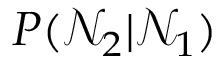Convert formula to latex. <formula><loc_0><loc_0><loc_500><loc_500>P ( \mathcal { N } _ { 2 } | \mathcal { N } _ { 1 } )</formula> 